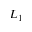<formula> <loc_0><loc_0><loc_500><loc_500>L _ { 1 }</formula> 